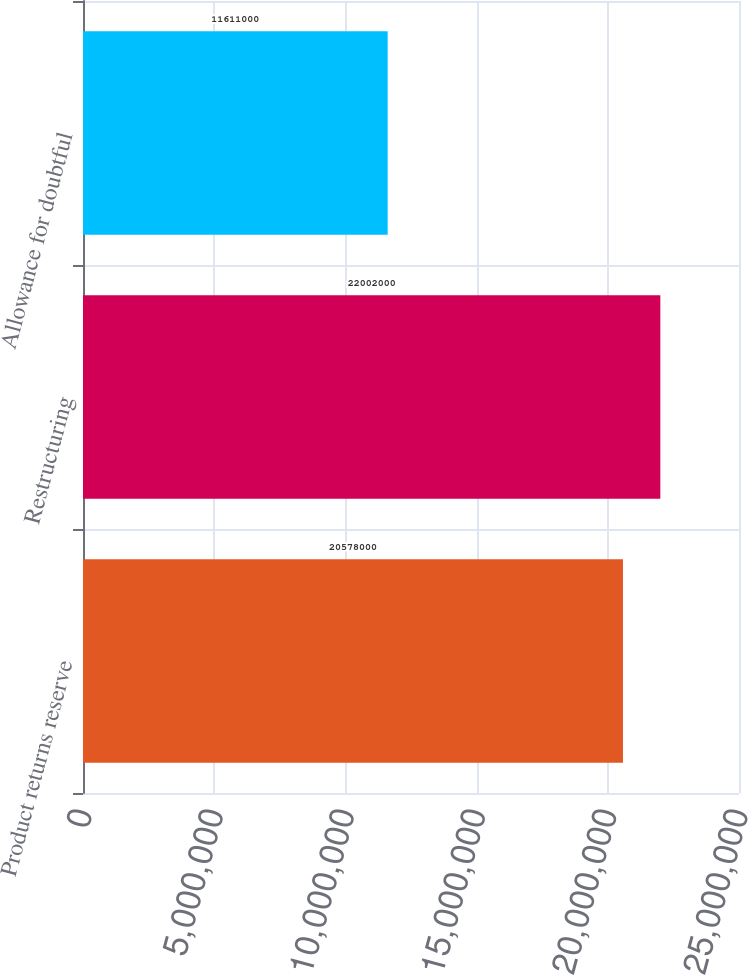<chart> <loc_0><loc_0><loc_500><loc_500><bar_chart><fcel>Product returns reserve<fcel>Restructuring<fcel>Allowance for doubtful<nl><fcel>2.0578e+07<fcel>2.2002e+07<fcel>1.1611e+07<nl></chart> 